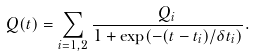<formula> <loc_0><loc_0><loc_500><loc_500>Q ( t ) = \sum _ { i = 1 , 2 } \frac { Q _ { i } } { 1 + \exp ( - ( t - t _ { i } ) / \delta t _ { i } ) } .</formula> 